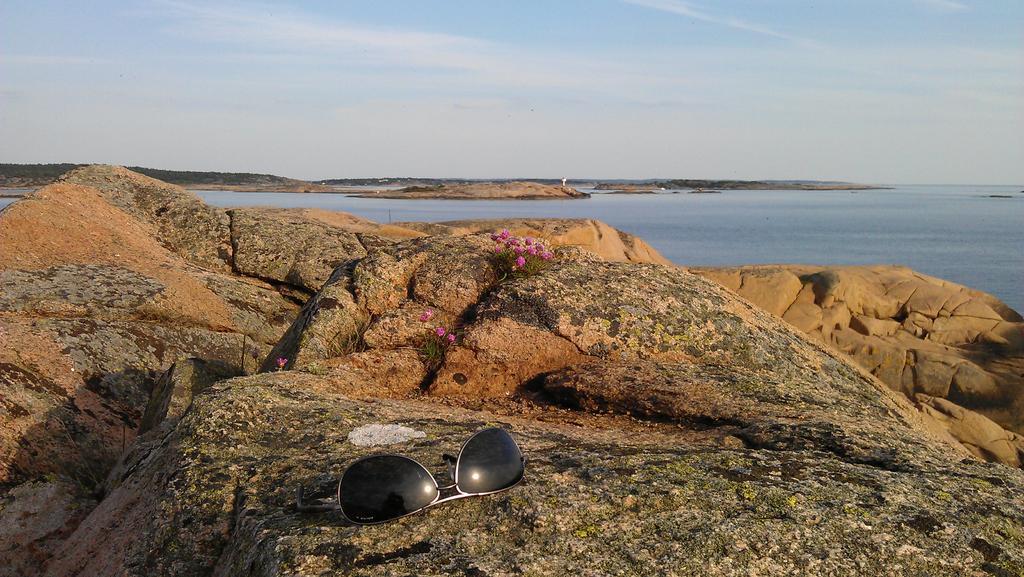Could you give a brief overview of what you see in this image? This is a goggles placed on the rock. These are the flowers. I can see the water flowing. 